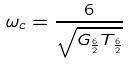Convert formula to latex. <formula><loc_0><loc_0><loc_500><loc_500>\omega _ { c } = \frac { 6 } { \sqrt { G _ { \frac { 6 } { 2 } } T _ { \frac { 6 } { 2 } } } }</formula> 